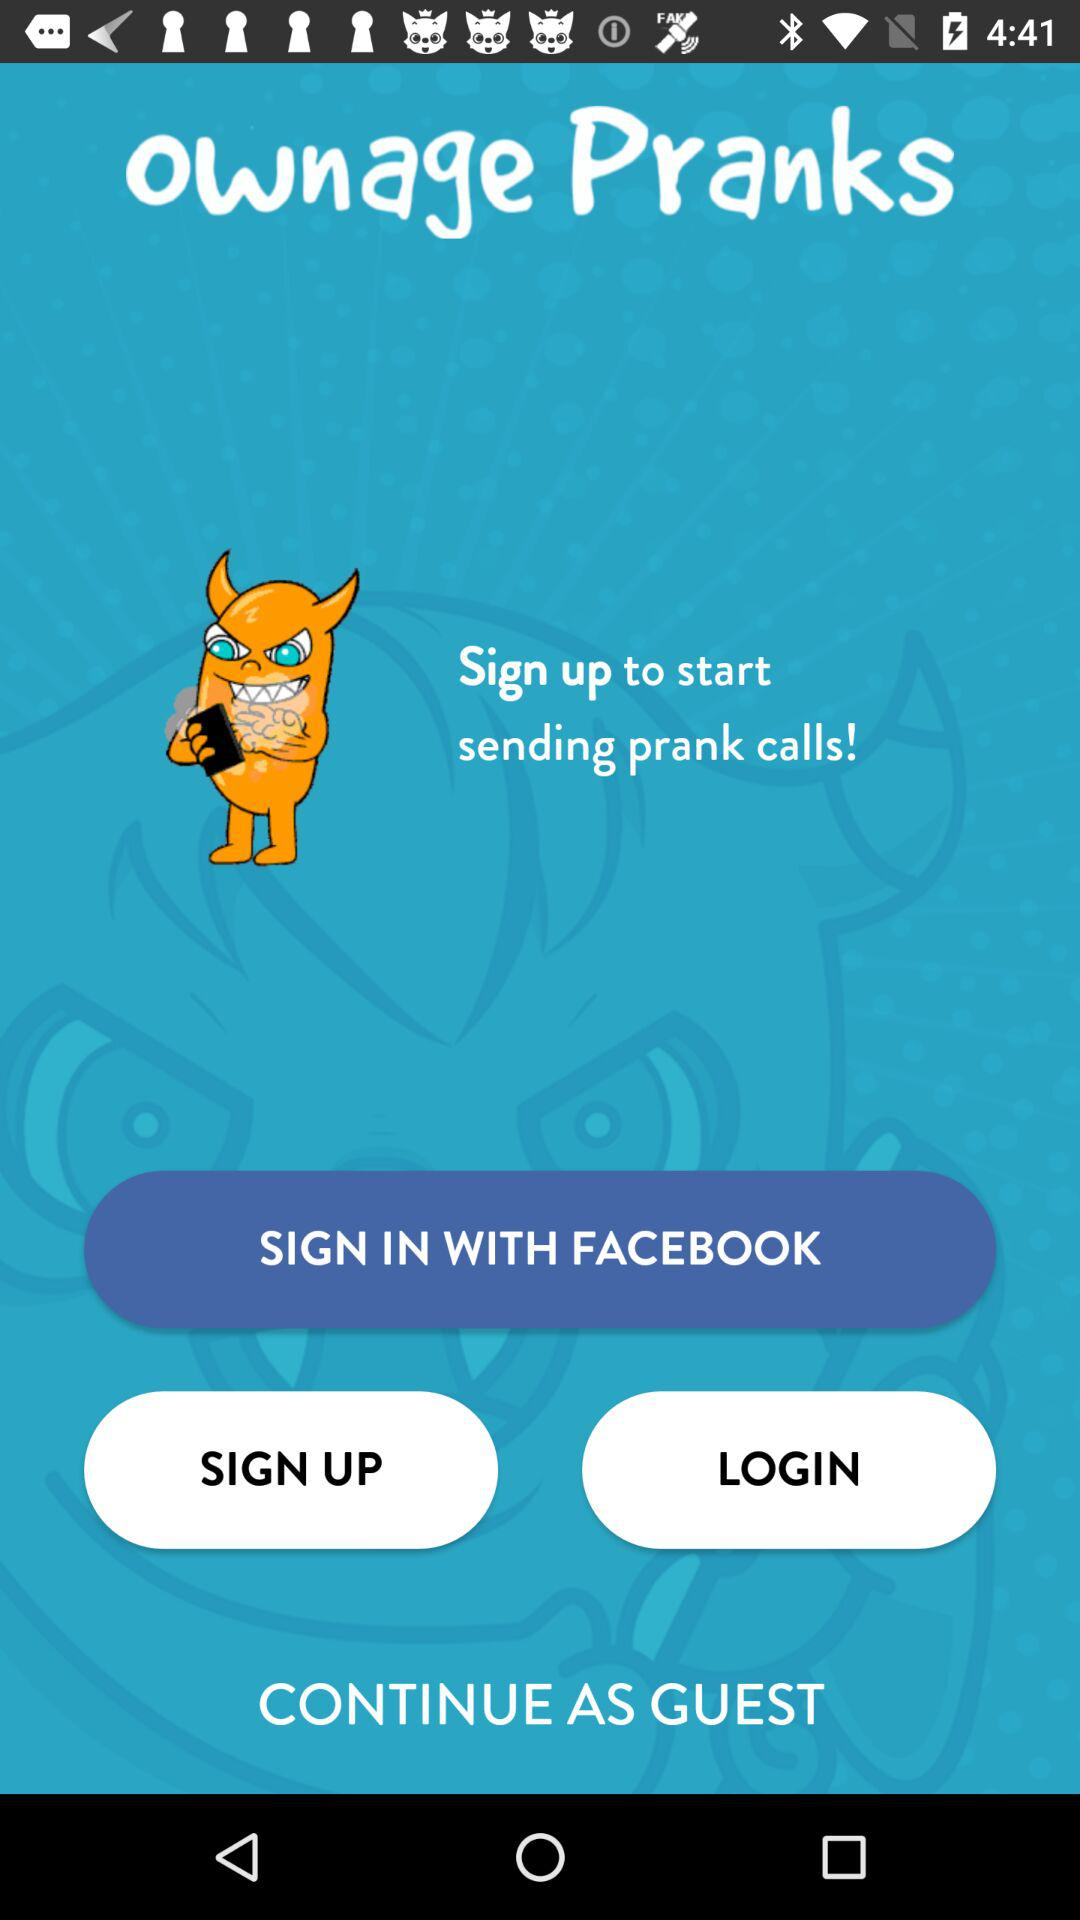What application is used for sign in? The application is "FACEBOOK". 